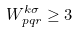<formula> <loc_0><loc_0><loc_500><loc_500>W _ { p q r } ^ { k \sigma } \geq 3</formula> 